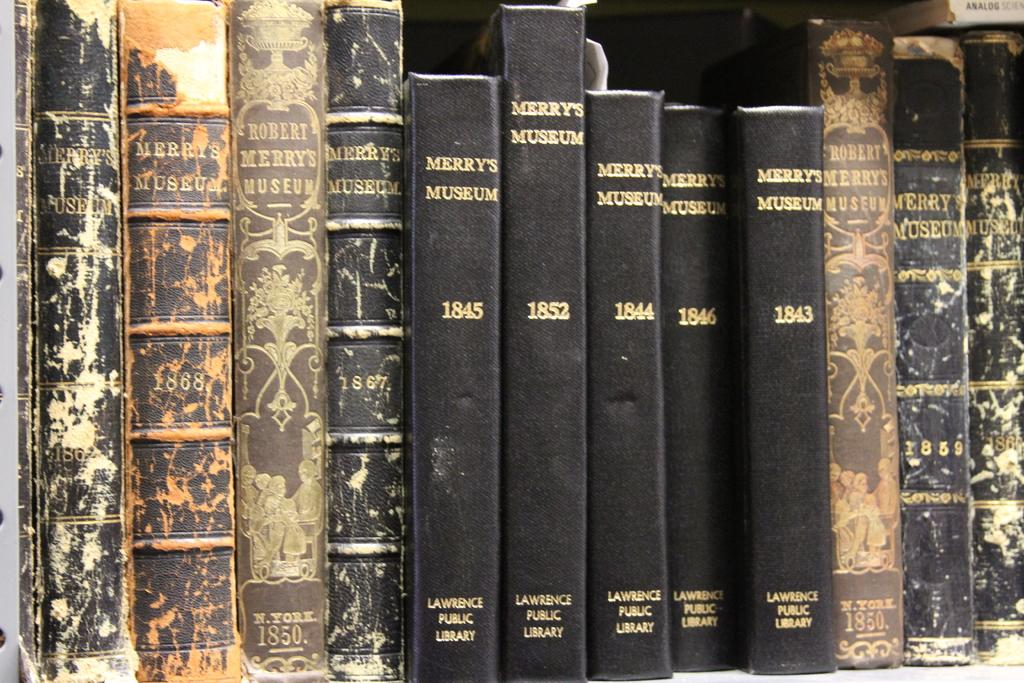Provide a one-sentence caption for the provided image. Volumes of Merry's museum from 1843 to 1852 sit together on a shelf. 